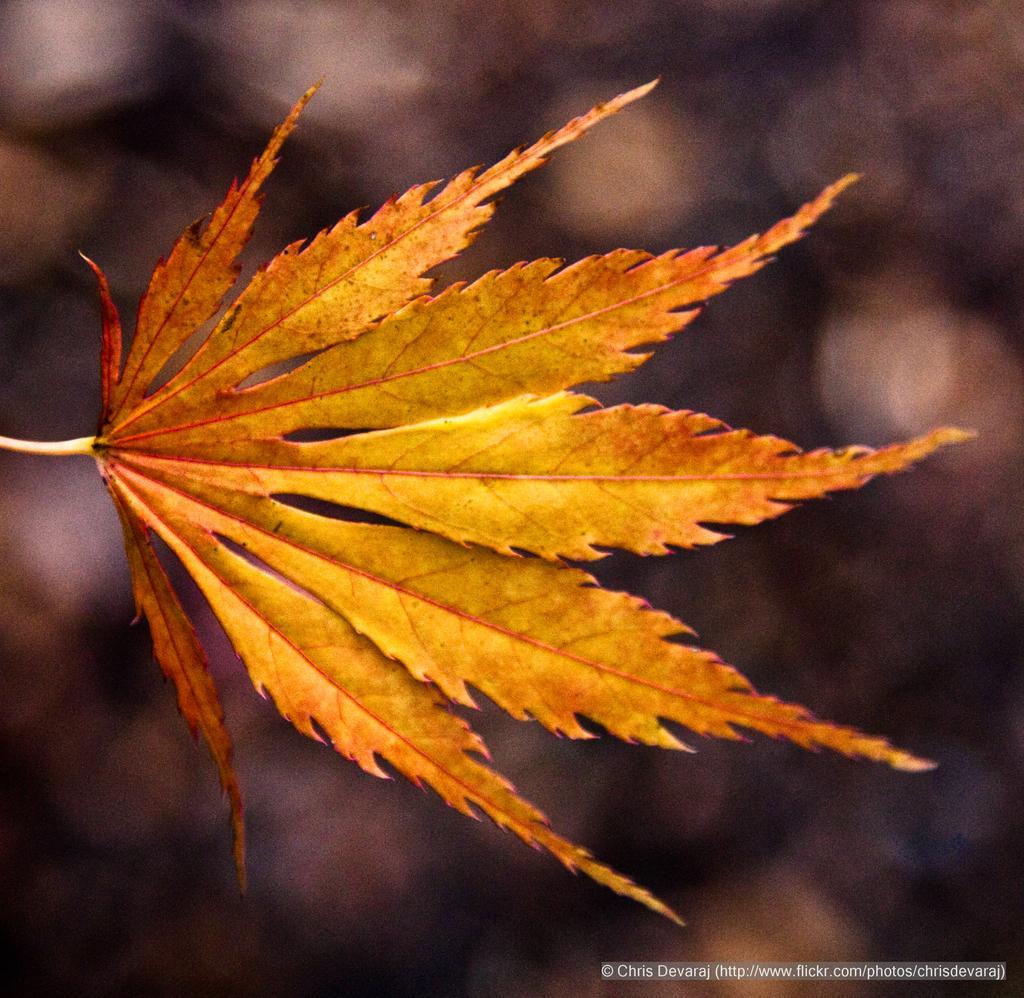Can you describe this image briefly? In this image in the front there are leaves and the background is blurry and at the bottom right of the image there is some text which is visible. 